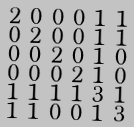<formula> <loc_0><loc_0><loc_500><loc_500>\begin{smallmatrix} 2 & 0 & 0 & 0 & 1 & 1 \\ 0 & 2 & 0 & 0 & 1 & 1 \\ 0 & 0 & 2 & 0 & 1 & 0 \\ 0 & 0 & 0 & 2 & 1 & 0 \\ 1 & 1 & 1 & 1 & 3 & 1 \\ 1 & 1 & 0 & 0 & 1 & 3 \end{smallmatrix}</formula> 